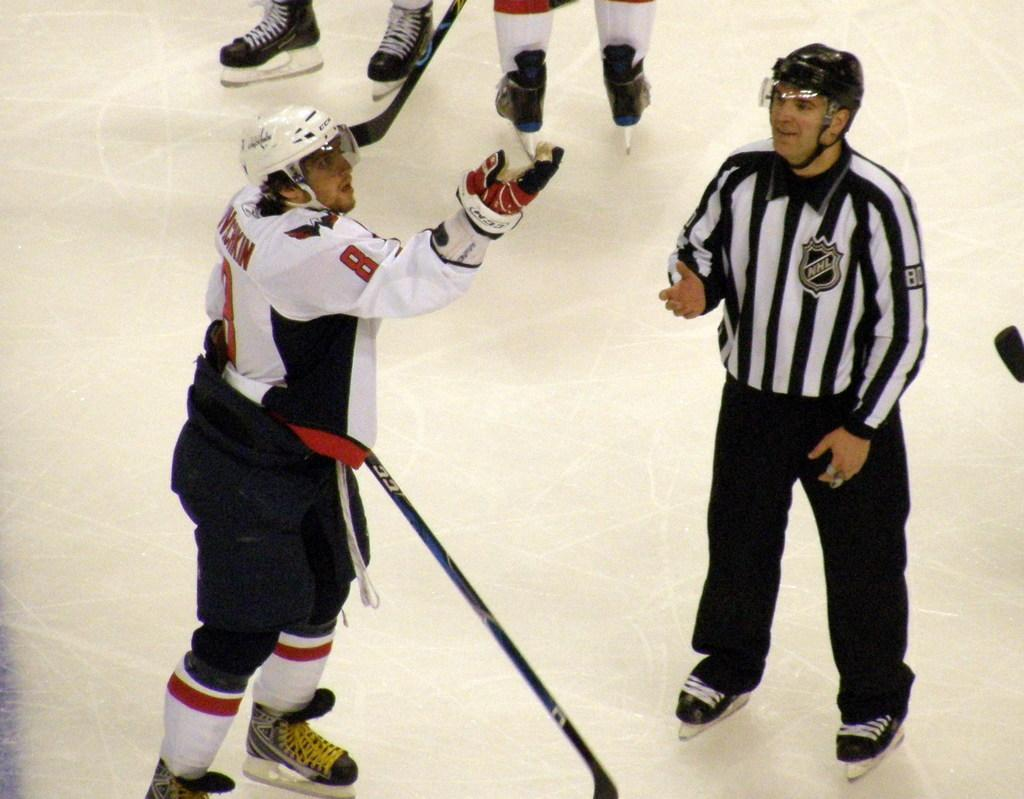How many people are in the image? There are two men in the image. What are the men doing in the image? The men are skating on the ground. Can you describe any other people in the image? The legs of two other people are visible behind the skating men. What type of trucks can be seen in the image? There are no trucks present in the image. Can you describe the worms that are visible on the skating men's legs? There are no worms visible on the skating men's legs in the image. 